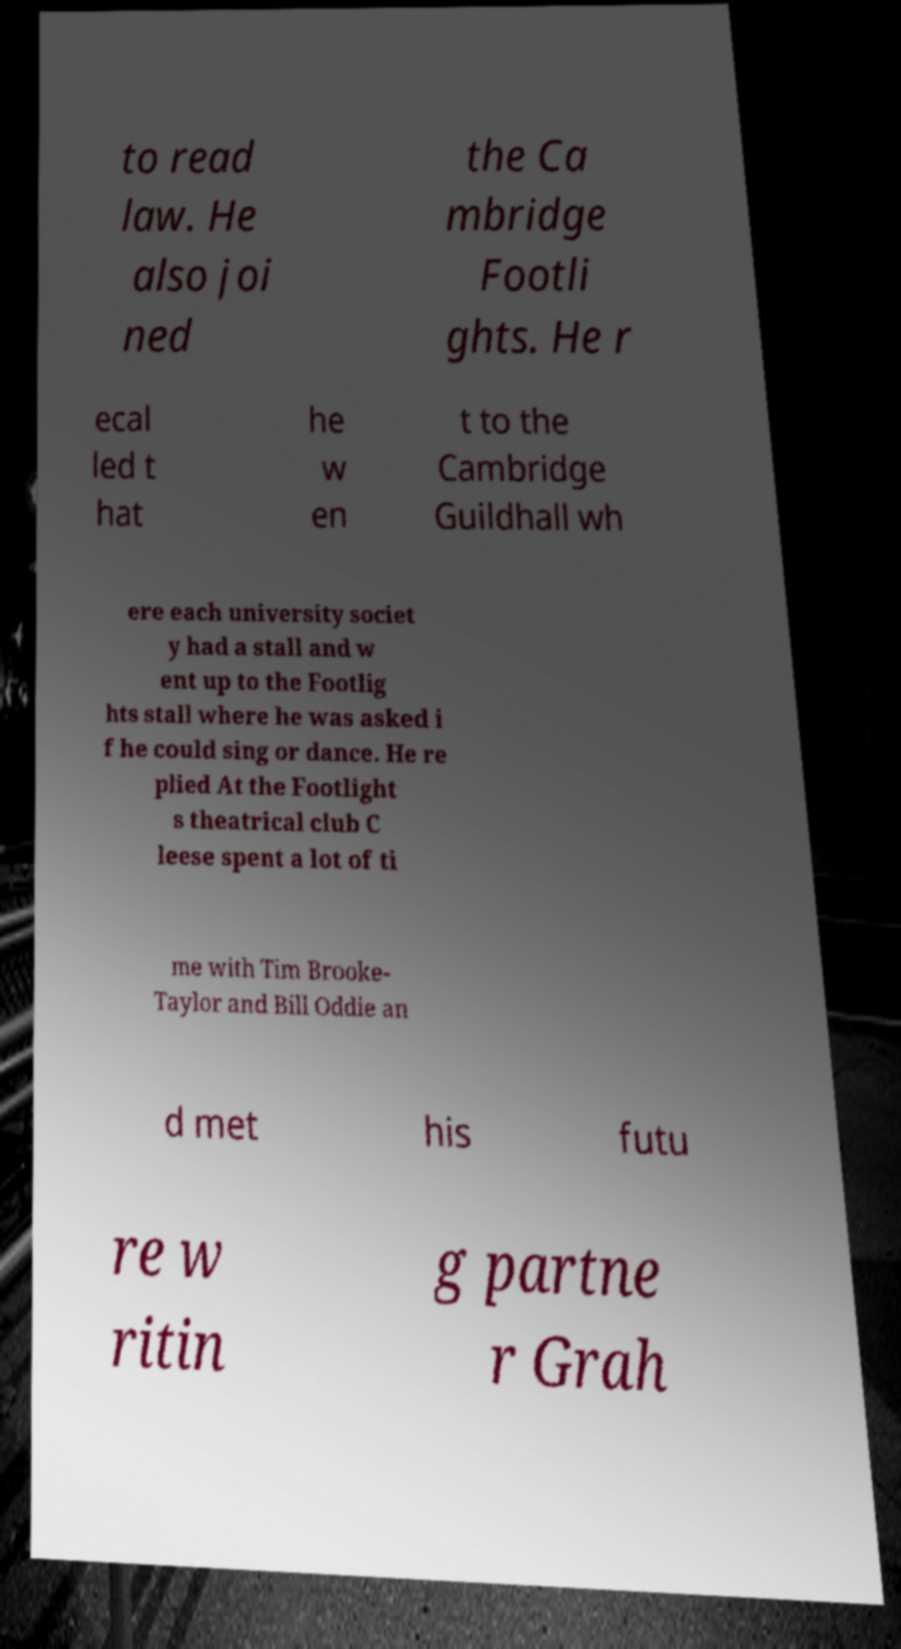Please read and relay the text visible in this image. What does it say? to read law. He also joi ned the Ca mbridge Footli ghts. He r ecal led t hat he w en t to the Cambridge Guildhall wh ere each university societ y had a stall and w ent up to the Footlig hts stall where he was asked i f he could sing or dance. He re plied At the Footlight s theatrical club C leese spent a lot of ti me with Tim Brooke- Taylor and Bill Oddie an d met his futu re w ritin g partne r Grah 